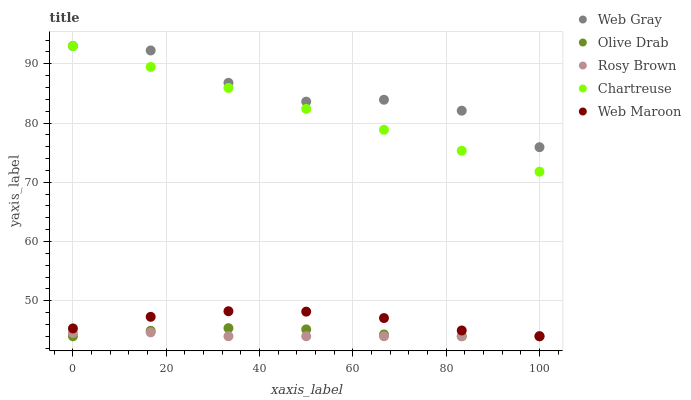Does Rosy Brown have the minimum area under the curve?
Answer yes or no. Yes. Does Web Gray have the maximum area under the curve?
Answer yes or no. Yes. Does Web Maroon have the minimum area under the curve?
Answer yes or no. No. Does Web Maroon have the maximum area under the curve?
Answer yes or no. No. Is Chartreuse the smoothest?
Answer yes or no. Yes. Is Web Gray the roughest?
Answer yes or no. Yes. Is Web Maroon the smoothest?
Answer yes or no. No. Is Web Maroon the roughest?
Answer yes or no. No. Does Rosy Brown have the lowest value?
Answer yes or no. Yes. Does Web Gray have the lowest value?
Answer yes or no. No. Does Chartreuse have the highest value?
Answer yes or no. Yes. Does Web Maroon have the highest value?
Answer yes or no. No. Is Olive Drab less than Chartreuse?
Answer yes or no. Yes. Is Web Gray greater than Web Maroon?
Answer yes or no. Yes. Does Olive Drab intersect Web Maroon?
Answer yes or no. Yes. Is Olive Drab less than Web Maroon?
Answer yes or no. No. Is Olive Drab greater than Web Maroon?
Answer yes or no. No. Does Olive Drab intersect Chartreuse?
Answer yes or no. No. 